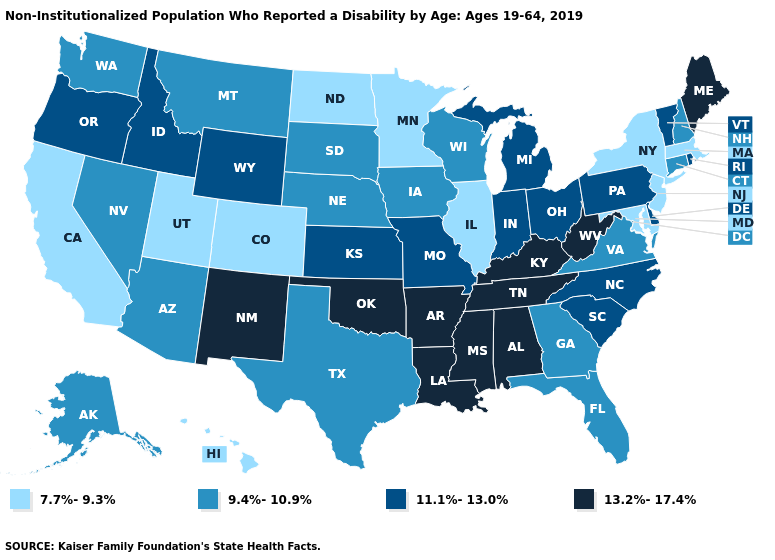Does Texas have the highest value in the USA?
Short answer required. No. Does Ohio have a higher value than West Virginia?
Write a very short answer. No. What is the lowest value in the Northeast?
Quick response, please. 7.7%-9.3%. Among the states that border Wisconsin , which have the highest value?
Short answer required. Michigan. What is the value of Missouri?
Short answer required. 11.1%-13.0%. Among the states that border North Carolina , does Tennessee have the lowest value?
Answer briefly. No. What is the lowest value in the USA?
Give a very brief answer. 7.7%-9.3%. Does Minnesota have the highest value in the MidWest?
Give a very brief answer. No. Name the states that have a value in the range 13.2%-17.4%?
Keep it brief. Alabama, Arkansas, Kentucky, Louisiana, Maine, Mississippi, New Mexico, Oklahoma, Tennessee, West Virginia. What is the highest value in the USA?
Give a very brief answer. 13.2%-17.4%. Name the states that have a value in the range 13.2%-17.4%?
Answer briefly. Alabama, Arkansas, Kentucky, Louisiana, Maine, Mississippi, New Mexico, Oklahoma, Tennessee, West Virginia. Which states have the highest value in the USA?
Be succinct. Alabama, Arkansas, Kentucky, Louisiana, Maine, Mississippi, New Mexico, Oklahoma, Tennessee, West Virginia. What is the lowest value in the USA?
Short answer required. 7.7%-9.3%. How many symbols are there in the legend?
Write a very short answer. 4. 